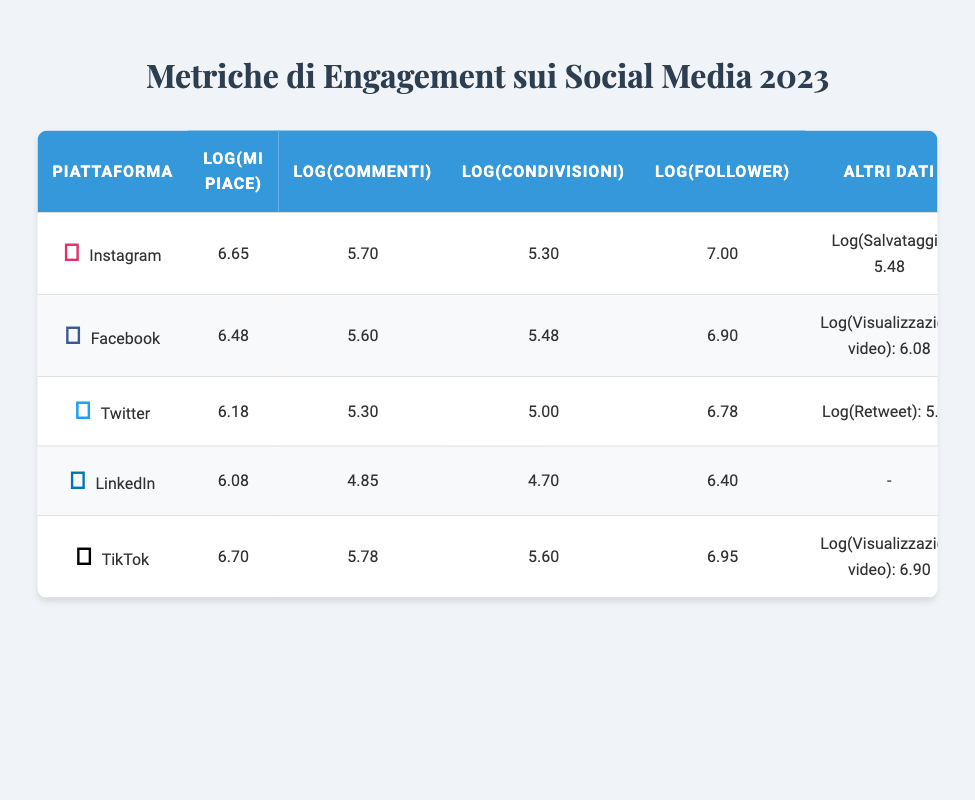What are the log values for likes on TikTok? In the table, the log value for likes on TikTok is directly listed as 6.70.
Answer: 6.70 Which platform has the highest log value for followers? By comparing the log values of followers across all platforms, Instagram has 7.00, which is the highest among them.
Answer: Instagram What is the total log value of shares across all platforms? The log values of shares are 5.30 (Instagram) + 5.48 (Facebook) + 5.00 (Twitter) + 4.70 (LinkedIn) + 5.60 (TikTok). Adding these values gives: 5.30 + 5.48 + 5.00 + 4.70 + 5.60 = 26.08.
Answer: 26.08 Is it true that LinkedIn has more log value for comments than Twitter? The log value for comments on LinkedIn is 4.85 and on Twitter it is 5.30. Since 4.85 is less than 5.30, this statement is false.
Answer: No What is the average log value of likes across all platforms? To find the average, sum the log values for likes: 6.65 (Instagram) + 6.48 (Facebook) + 6.18 (Twitter) + 6.08 (LinkedIn) + 6.70 (TikTok) = 31.09. There are 5 platforms, so divide by 5: 31.09 / 5 = 6.218.
Answer: 6.22 Which platform has the highest log value for comments? The log values for comments are 5.70 (Instagram), 5.60 (Facebook), 5.30 (Twitter), 4.85 (LinkedIn), and 5.78 (TikTok). The highest value is for TikTok at 5.78.
Answer: TikTok What is the difference in log values of likes between Instagram and Facebook? The log value for likes on Instagram is 6.65 and for Facebook is 6.48. The difference is calculated by subtracting 6.48 from 6.65: 6.65 - 6.48 = 0.17.
Answer: 0.17 